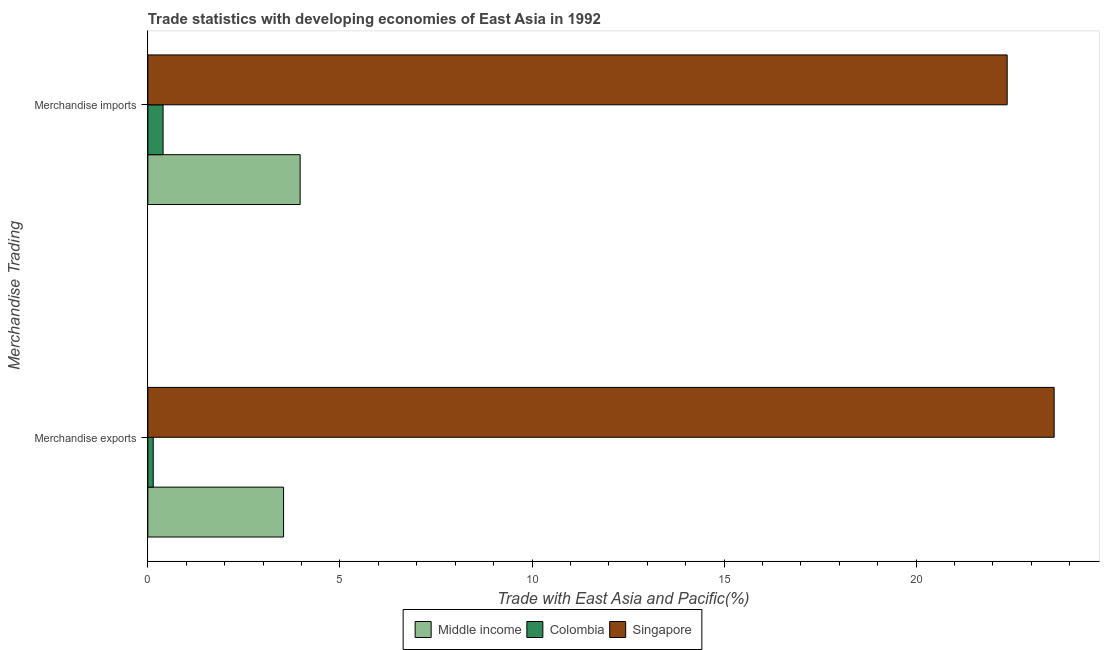How many groups of bars are there?
Your answer should be compact. 2. Are the number of bars per tick equal to the number of legend labels?
Provide a short and direct response. Yes. How many bars are there on the 1st tick from the bottom?
Your answer should be compact. 3. What is the label of the 2nd group of bars from the top?
Provide a succinct answer. Merchandise exports. What is the merchandise exports in Middle income?
Give a very brief answer. 3.53. Across all countries, what is the maximum merchandise exports?
Your answer should be compact. 23.59. Across all countries, what is the minimum merchandise imports?
Ensure brevity in your answer.  0.4. In which country was the merchandise imports maximum?
Your response must be concise. Singapore. What is the total merchandise imports in the graph?
Your answer should be compact. 26.73. What is the difference between the merchandise imports in Middle income and that in Singapore?
Offer a very short reply. -18.41. What is the difference between the merchandise imports in Colombia and the merchandise exports in Singapore?
Keep it short and to the point. -23.2. What is the average merchandise exports per country?
Provide a succinct answer. 9.09. What is the difference between the merchandise exports and merchandise imports in Singapore?
Keep it short and to the point. 1.22. In how many countries, is the merchandise imports greater than 10 %?
Offer a terse response. 1. What is the ratio of the merchandise imports in Middle income to that in Colombia?
Provide a succinct answer. 10.01. Is the merchandise imports in Singapore less than that in Colombia?
Your answer should be compact. No. In how many countries, is the merchandise imports greater than the average merchandise imports taken over all countries?
Give a very brief answer. 1. What does the 3rd bar from the top in Merchandise exports represents?
Your response must be concise. Middle income. What does the 3rd bar from the bottom in Merchandise imports represents?
Make the answer very short. Singapore. How many bars are there?
Keep it short and to the point. 6. Are all the bars in the graph horizontal?
Ensure brevity in your answer.  Yes. Does the graph contain grids?
Make the answer very short. No. Where does the legend appear in the graph?
Provide a short and direct response. Bottom center. How many legend labels are there?
Your answer should be compact. 3. How are the legend labels stacked?
Ensure brevity in your answer.  Horizontal. What is the title of the graph?
Your response must be concise. Trade statistics with developing economies of East Asia in 1992. Does "Bahrain" appear as one of the legend labels in the graph?
Provide a short and direct response. No. What is the label or title of the X-axis?
Ensure brevity in your answer.  Trade with East Asia and Pacific(%). What is the label or title of the Y-axis?
Provide a succinct answer. Merchandise Trading. What is the Trade with East Asia and Pacific(%) of Middle income in Merchandise exports?
Your answer should be compact. 3.53. What is the Trade with East Asia and Pacific(%) of Colombia in Merchandise exports?
Give a very brief answer. 0.14. What is the Trade with East Asia and Pacific(%) in Singapore in Merchandise exports?
Make the answer very short. 23.59. What is the Trade with East Asia and Pacific(%) of Middle income in Merchandise imports?
Offer a very short reply. 3.96. What is the Trade with East Asia and Pacific(%) in Colombia in Merchandise imports?
Your answer should be compact. 0.4. What is the Trade with East Asia and Pacific(%) of Singapore in Merchandise imports?
Give a very brief answer. 22.37. Across all Merchandise Trading, what is the maximum Trade with East Asia and Pacific(%) in Middle income?
Provide a succinct answer. 3.96. Across all Merchandise Trading, what is the maximum Trade with East Asia and Pacific(%) in Colombia?
Keep it short and to the point. 0.4. Across all Merchandise Trading, what is the maximum Trade with East Asia and Pacific(%) of Singapore?
Provide a short and direct response. 23.59. Across all Merchandise Trading, what is the minimum Trade with East Asia and Pacific(%) of Middle income?
Offer a terse response. 3.53. Across all Merchandise Trading, what is the minimum Trade with East Asia and Pacific(%) in Colombia?
Ensure brevity in your answer.  0.14. Across all Merchandise Trading, what is the minimum Trade with East Asia and Pacific(%) of Singapore?
Provide a short and direct response. 22.37. What is the total Trade with East Asia and Pacific(%) of Middle income in the graph?
Offer a terse response. 7.5. What is the total Trade with East Asia and Pacific(%) in Colombia in the graph?
Give a very brief answer. 0.54. What is the total Trade with East Asia and Pacific(%) of Singapore in the graph?
Your answer should be compact. 45.96. What is the difference between the Trade with East Asia and Pacific(%) in Middle income in Merchandise exports and that in Merchandise imports?
Provide a short and direct response. -0.43. What is the difference between the Trade with East Asia and Pacific(%) of Colombia in Merchandise exports and that in Merchandise imports?
Your answer should be very brief. -0.26. What is the difference between the Trade with East Asia and Pacific(%) of Singapore in Merchandise exports and that in Merchandise imports?
Keep it short and to the point. 1.22. What is the difference between the Trade with East Asia and Pacific(%) in Middle income in Merchandise exports and the Trade with East Asia and Pacific(%) in Colombia in Merchandise imports?
Your answer should be compact. 3.14. What is the difference between the Trade with East Asia and Pacific(%) of Middle income in Merchandise exports and the Trade with East Asia and Pacific(%) of Singapore in Merchandise imports?
Give a very brief answer. -18.84. What is the difference between the Trade with East Asia and Pacific(%) in Colombia in Merchandise exports and the Trade with East Asia and Pacific(%) in Singapore in Merchandise imports?
Offer a very short reply. -22.23. What is the average Trade with East Asia and Pacific(%) in Middle income per Merchandise Trading?
Your answer should be very brief. 3.75. What is the average Trade with East Asia and Pacific(%) of Colombia per Merchandise Trading?
Ensure brevity in your answer.  0.27. What is the average Trade with East Asia and Pacific(%) of Singapore per Merchandise Trading?
Keep it short and to the point. 22.98. What is the difference between the Trade with East Asia and Pacific(%) in Middle income and Trade with East Asia and Pacific(%) in Colombia in Merchandise exports?
Offer a very short reply. 3.39. What is the difference between the Trade with East Asia and Pacific(%) in Middle income and Trade with East Asia and Pacific(%) in Singapore in Merchandise exports?
Provide a succinct answer. -20.06. What is the difference between the Trade with East Asia and Pacific(%) of Colombia and Trade with East Asia and Pacific(%) of Singapore in Merchandise exports?
Your answer should be compact. -23.45. What is the difference between the Trade with East Asia and Pacific(%) in Middle income and Trade with East Asia and Pacific(%) in Colombia in Merchandise imports?
Your answer should be compact. 3.57. What is the difference between the Trade with East Asia and Pacific(%) of Middle income and Trade with East Asia and Pacific(%) of Singapore in Merchandise imports?
Your answer should be very brief. -18.41. What is the difference between the Trade with East Asia and Pacific(%) in Colombia and Trade with East Asia and Pacific(%) in Singapore in Merchandise imports?
Your answer should be very brief. -21.97. What is the ratio of the Trade with East Asia and Pacific(%) of Middle income in Merchandise exports to that in Merchandise imports?
Keep it short and to the point. 0.89. What is the ratio of the Trade with East Asia and Pacific(%) in Colombia in Merchandise exports to that in Merchandise imports?
Provide a short and direct response. 0.35. What is the ratio of the Trade with East Asia and Pacific(%) of Singapore in Merchandise exports to that in Merchandise imports?
Offer a terse response. 1.05. What is the difference between the highest and the second highest Trade with East Asia and Pacific(%) of Middle income?
Ensure brevity in your answer.  0.43. What is the difference between the highest and the second highest Trade with East Asia and Pacific(%) in Colombia?
Make the answer very short. 0.26. What is the difference between the highest and the second highest Trade with East Asia and Pacific(%) of Singapore?
Give a very brief answer. 1.22. What is the difference between the highest and the lowest Trade with East Asia and Pacific(%) in Middle income?
Your answer should be compact. 0.43. What is the difference between the highest and the lowest Trade with East Asia and Pacific(%) of Colombia?
Give a very brief answer. 0.26. What is the difference between the highest and the lowest Trade with East Asia and Pacific(%) in Singapore?
Your answer should be very brief. 1.22. 